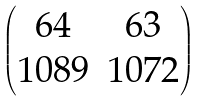<formula> <loc_0><loc_0><loc_500><loc_500>\begin{pmatrix} 6 4 & 6 3 \\ 1 0 8 9 & 1 0 7 2 \end{pmatrix}</formula> 